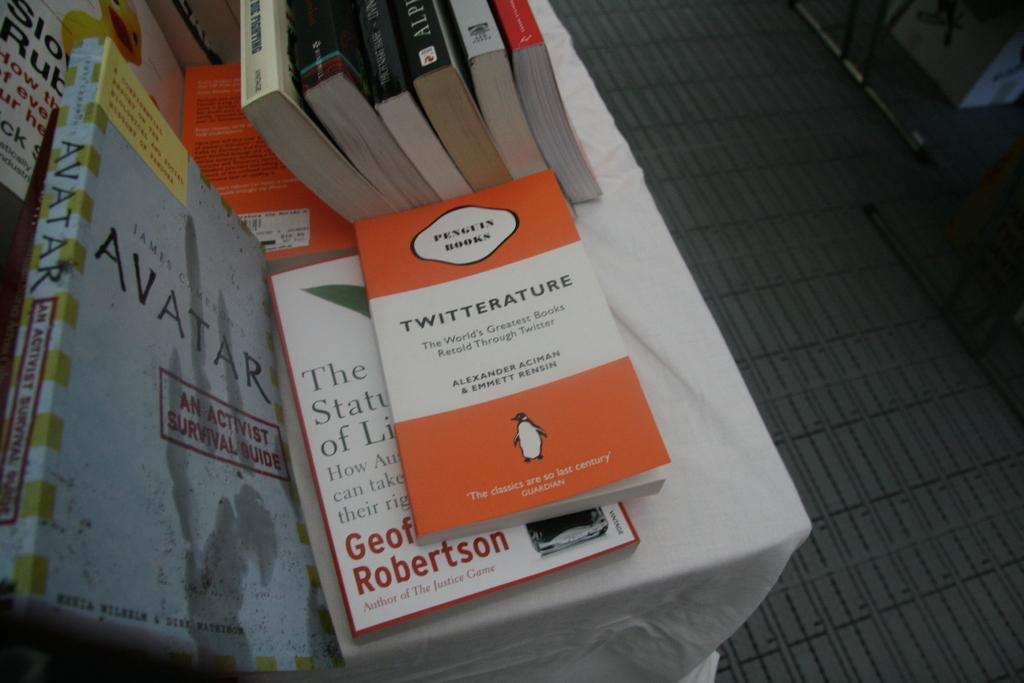<image>
Write a terse but informative summary of the picture. A Penguin Book has an orange and white cover. 